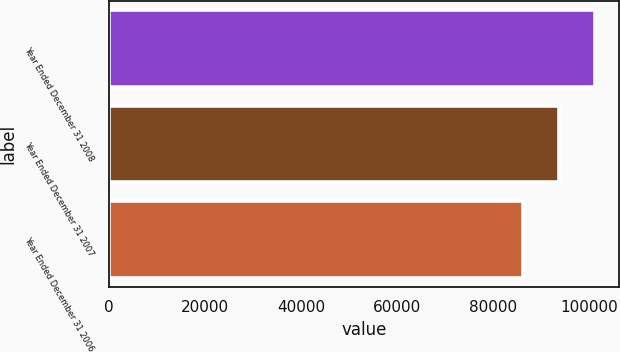Convert chart to OTSL. <chart><loc_0><loc_0><loc_500><loc_500><bar_chart><fcel>Year Ended December 31 2008<fcel>Year Ended December 31 2007<fcel>Year Ended December 31 2006<nl><fcel>101123<fcel>93637.9<fcel>86153<nl></chart> 